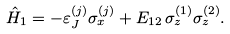<formula> <loc_0><loc_0><loc_500><loc_500>\hat { H } _ { 1 } = - \varepsilon ^ { ( j ) } _ { J } \sigma ^ { ( j ) } _ { x } + E _ { 1 2 } \, \sigma _ { z } ^ { ( 1 ) } \sigma _ { z } ^ { ( 2 ) } .</formula> 